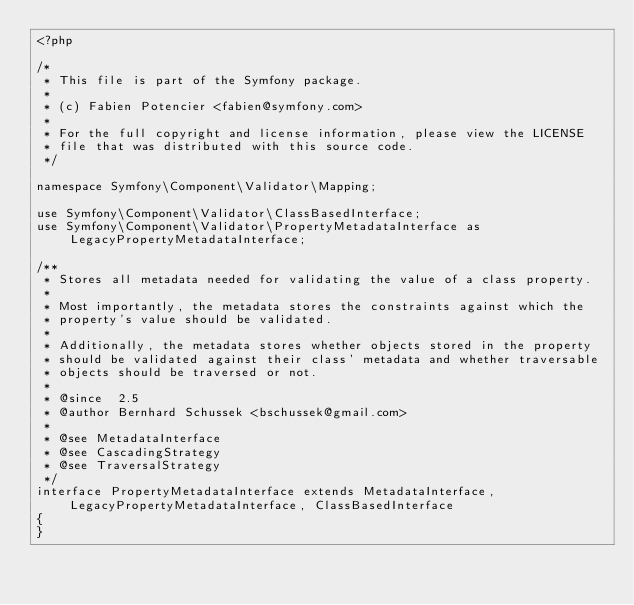Convert code to text. <code><loc_0><loc_0><loc_500><loc_500><_PHP_><?php

/*
 * This file is part of the Symfony package.
 *
 * (c) Fabien Potencier <fabien@symfony.com>
 *
 * For the full copyright and license information, please view the LICENSE
 * file that was distributed with this source code.
 */

namespace Symfony\Component\Validator\Mapping;

use Symfony\Component\Validator\ClassBasedInterface;
use Symfony\Component\Validator\PropertyMetadataInterface as LegacyPropertyMetadataInterface;

/**
 * Stores all metadata needed for validating the value of a class property.
 *
 * Most importantly, the metadata stores the constraints against which the
 * property's value should be validated.
 *
 * Additionally, the metadata stores whether objects stored in the property
 * should be validated against their class' metadata and whether traversable
 * objects should be traversed or not.
 *
 * @since  2.5
 * @author Bernhard Schussek <bschussek@gmail.com>
 *
 * @see MetadataInterface
 * @see CascadingStrategy
 * @see TraversalStrategy
 */
interface PropertyMetadataInterface extends MetadataInterface, LegacyPropertyMetadataInterface, ClassBasedInterface
{
}
</code> 